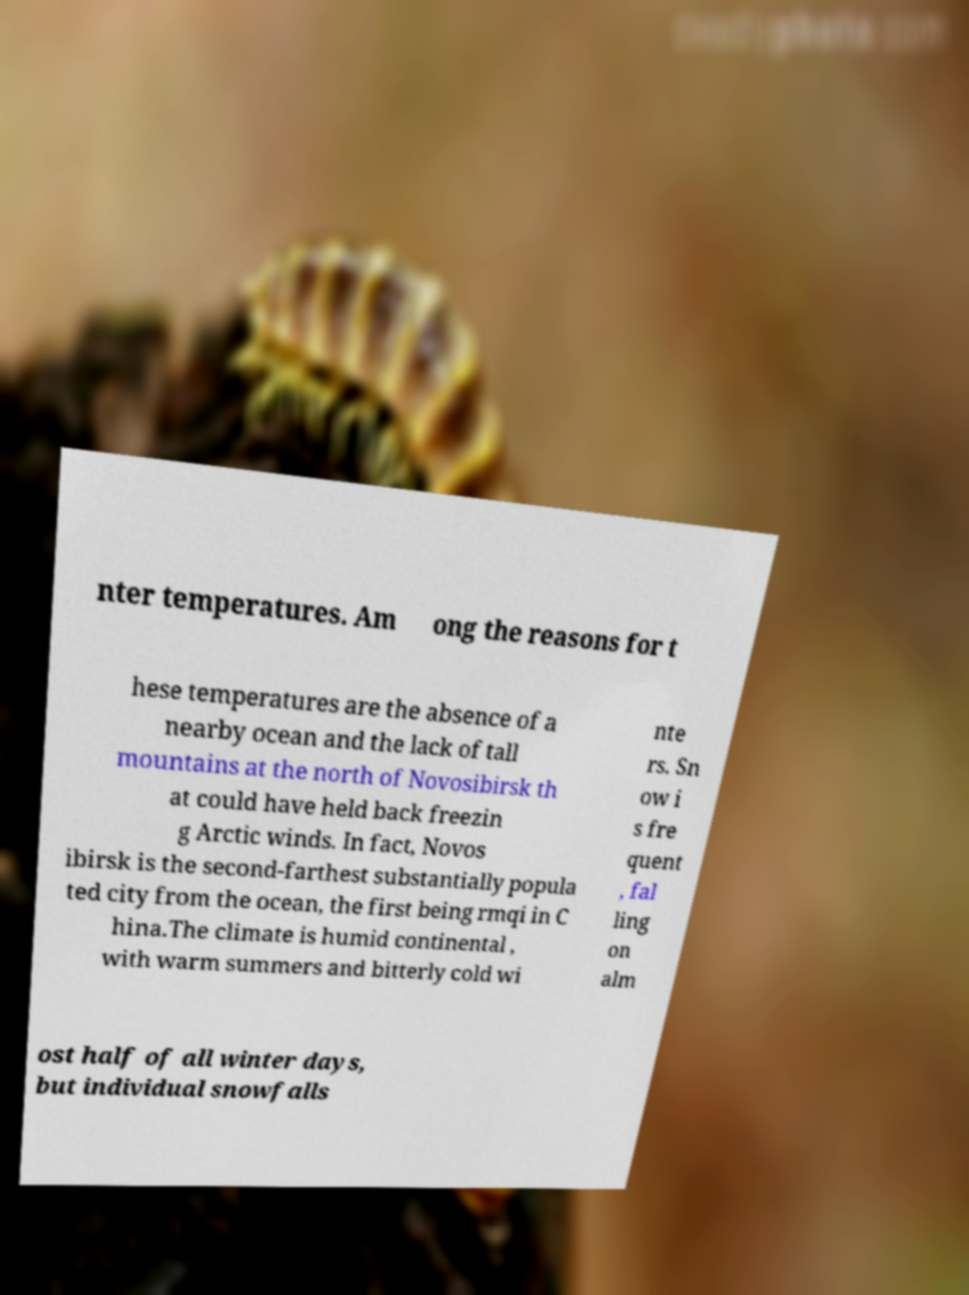There's text embedded in this image that I need extracted. Can you transcribe it verbatim? nter temperatures. Am ong the reasons for t hese temperatures are the absence of a nearby ocean and the lack of tall mountains at the north of Novosibirsk th at could have held back freezin g Arctic winds. In fact, Novos ibirsk is the second-farthest substantially popula ted city from the ocean, the first being rmqi in C hina.The climate is humid continental , with warm summers and bitterly cold wi nte rs. Sn ow i s fre quent , fal ling on alm ost half of all winter days, but individual snowfalls 